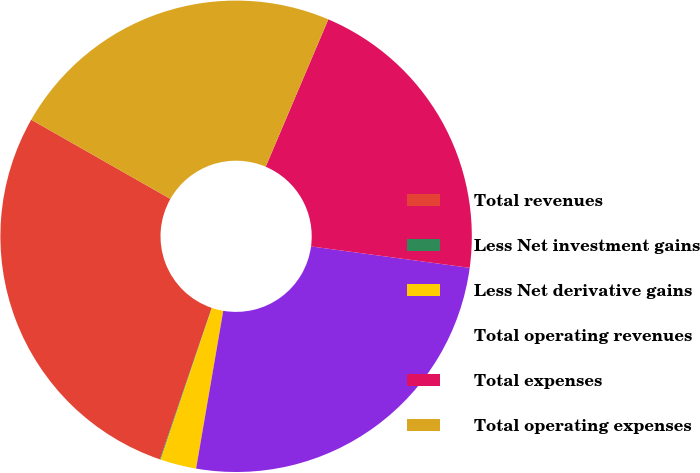Convert chart. <chart><loc_0><loc_0><loc_500><loc_500><pie_chart><fcel>Total revenues<fcel>Less Net investment gains<fcel>Less Net derivative gains<fcel>Total operating revenues<fcel>Total expenses<fcel>Total operating expenses<nl><fcel>28.0%<fcel>0.05%<fcel>2.47%<fcel>25.58%<fcel>20.74%<fcel>23.16%<nl></chart> 